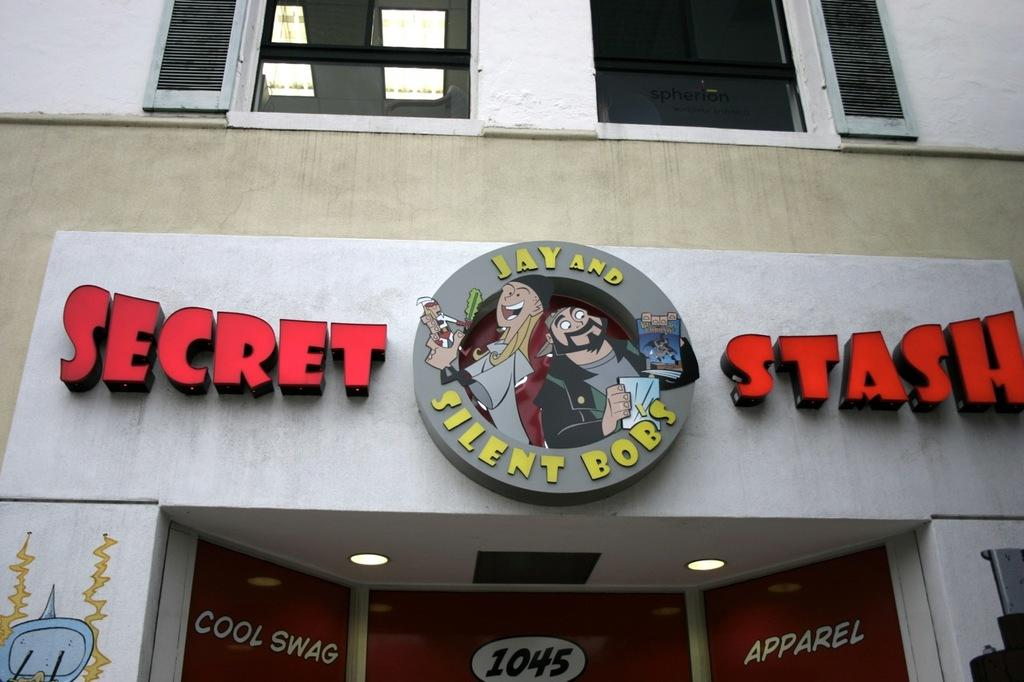<image>
Share a concise interpretation of the image provided. Secret Stash Jay and Silent Bobs store front. 